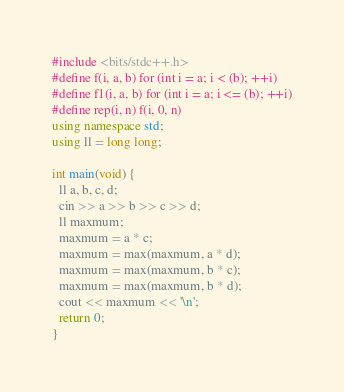Convert code to text. <code><loc_0><loc_0><loc_500><loc_500><_C++_>#include <bits/stdc++.h>
#define f(i, a, b) for (int i = a; i < (b); ++i)
#define f1(i, a, b) for (int i = a; i <= (b); ++i)
#define rep(i, n) f(i, 0, n)
using namespace std;
using ll = long long;

int main(void) {
  ll a, b, c, d;
  cin >> a >> b >> c >> d;
  ll maxmum;
  maxmum = a * c;
  maxmum = max(maxmum, a * d);
  maxmum = max(maxmum, b * c);
  maxmum = max(maxmum, b * d);
  cout << maxmum << '\n';
  return 0;
}</code> 